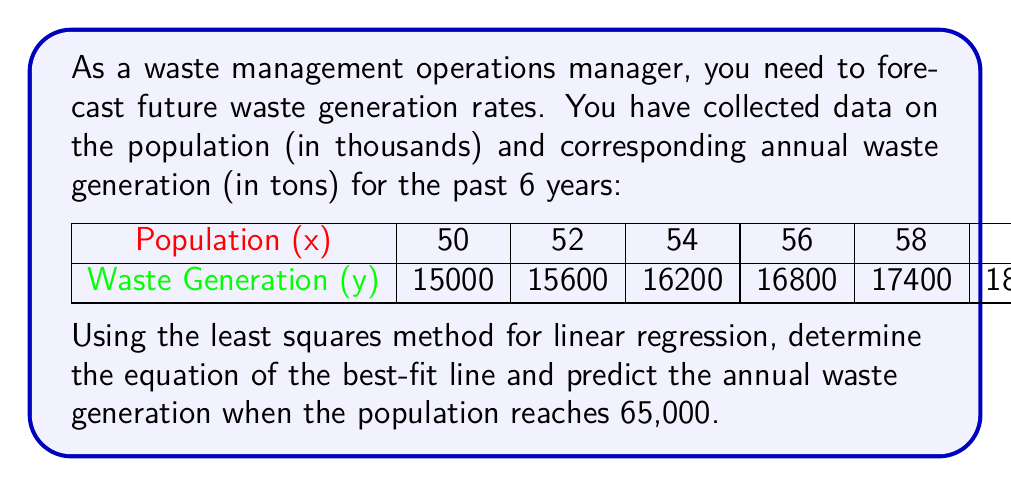Can you solve this math problem? 1. First, we need to calculate the necessary sums for the least squares method:
   $n = 6$
   $\sum x = 330$
   $\sum y = 99000$
   $\sum xy = 5,478,000$
   $\sum x^2 = 18,260$

2. Calculate the slope (m) using the formula:
   $$m = \frac{n\sum xy - \sum x \sum y}{n\sum x^2 - (\sum x)^2}$$
   $$m = \frac{6(5,478,000) - 330(99000)}{6(18,260) - 330^2} = 300$$

3. Calculate the y-intercept (b) using the formula:
   $$b = \frac{\sum y - m\sum x}{n}$$
   $$b = \frac{99000 - 300(330)}{6} = 0$$

4. The equation of the best-fit line is:
   $$y = 300x + 0$$ or simply $$y = 300x$$

5. To predict the waste generation for a population of 65,000:
   $$y = 300(65) = 19,500$$

Therefore, when the population reaches 65,000, the predicted annual waste generation is 19,500 tons.
Answer: y = 300x; 19,500 tons 